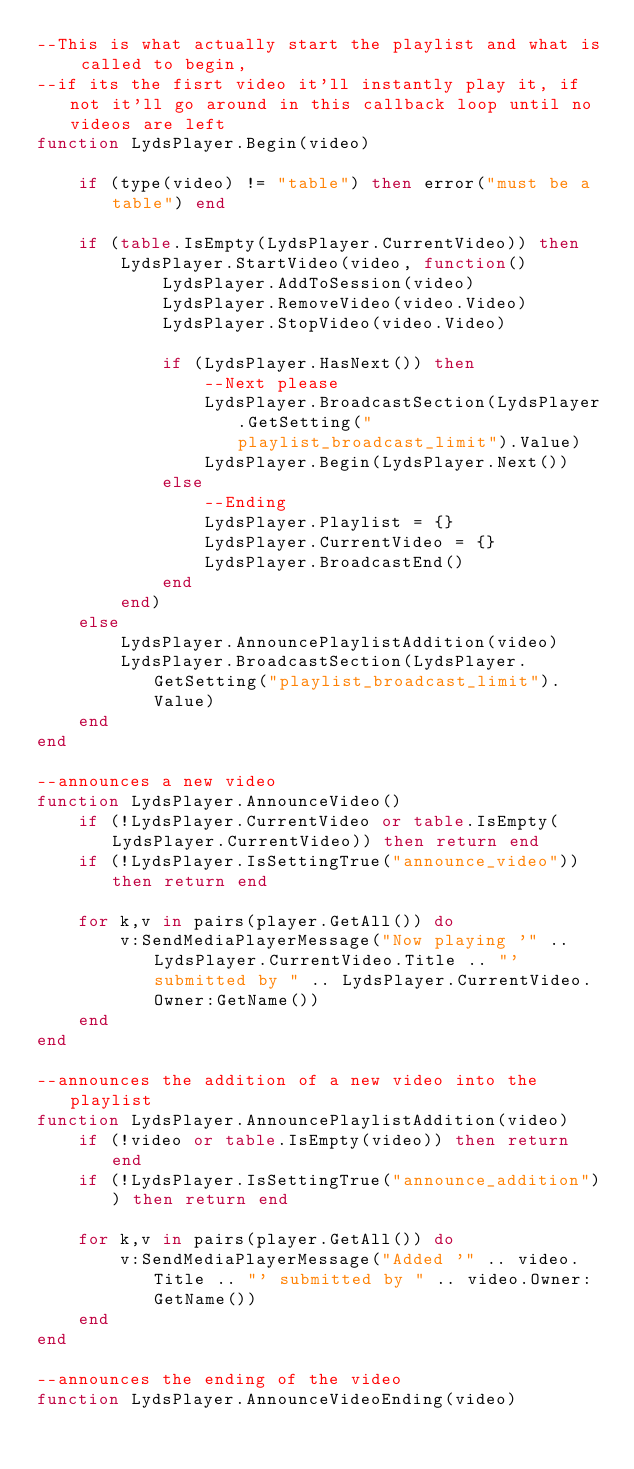<code> <loc_0><loc_0><loc_500><loc_500><_Lua_>--This is what actually start the playlist and what is called to begin,
--if its the fisrt video it'll instantly play it, if not it'll go around in this callback loop until no videos are left
function LydsPlayer.Begin(video)

	if (type(video) != "table") then error("must be a table") end

	if (table.IsEmpty(LydsPlayer.CurrentVideo)) then
		LydsPlayer.StartVideo(video, function()
			LydsPlayer.AddToSession(video)
			LydsPlayer.RemoveVideo(video.Video)
			LydsPlayer.StopVideo(video.Video)

			if (LydsPlayer.HasNext()) then
				--Next please
				LydsPlayer.BroadcastSection(LydsPlayer.GetSetting("playlist_broadcast_limit").Value)
				LydsPlayer.Begin(LydsPlayer.Next())
			else
				--Ending
				LydsPlayer.Playlist = {}
				LydsPlayer.CurrentVideo = {}
				LydsPlayer.BroadcastEnd()
			end
		end)
	else
		LydsPlayer.AnnouncePlaylistAddition(video)
		LydsPlayer.BroadcastSection(LydsPlayer.GetSetting("playlist_broadcast_limit").Value)
	end
end

--announces a new video
function LydsPlayer.AnnounceVideo()
	if (!LydsPlayer.CurrentVideo or table.IsEmpty(LydsPlayer.CurrentVideo)) then return end
	if (!LydsPlayer.IsSettingTrue("announce_video")) then return end

	for k,v in pairs(player.GetAll()) do
		v:SendMediaPlayerMessage("Now playing '" .. LydsPlayer.CurrentVideo.Title .. "' submitted by " .. LydsPlayer.CurrentVideo.Owner:GetName())
	end
end

--announces the addition of a new video into the playlist
function LydsPlayer.AnnouncePlaylistAddition(video)
	if (!video or table.IsEmpty(video)) then return end
	if (!LydsPlayer.IsSettingTrue("announce_addition")) then return end

	for k,v in pairs(player.GetAll()) do
		v:SendMediaPlayerMessage("Added '" .. video.Title .. "' submitted by " .. video.Owner:GetName())
	end
end

--announces the ending of the video
function LydsPlayer.AnnounceVideoEnding(video)</code> 